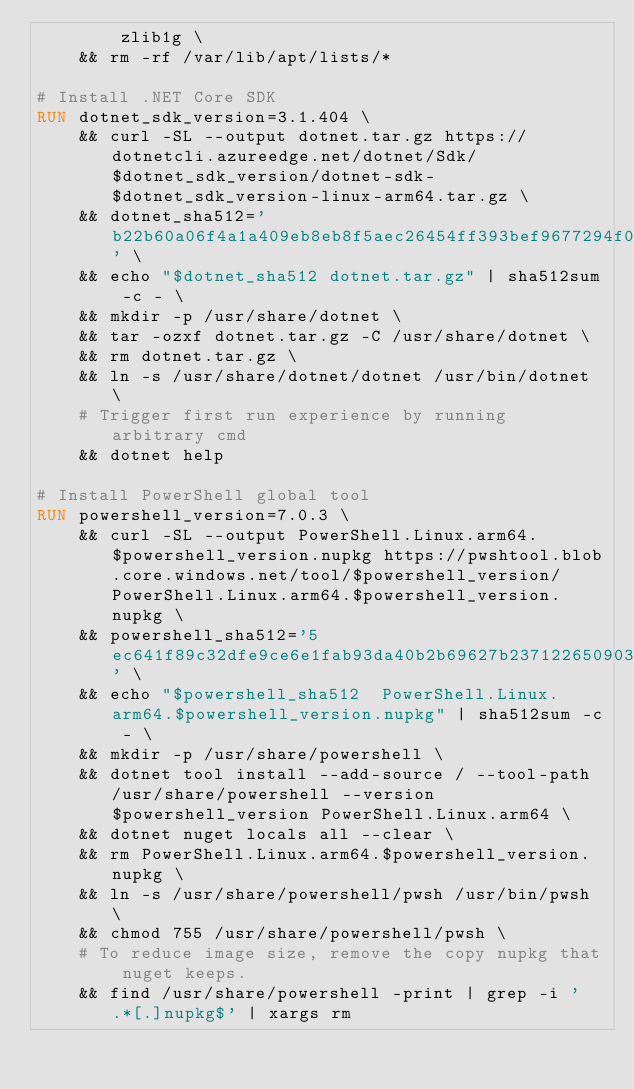<code> <loc_0><loc_0><loc_500><loc_500><_Dockerfile_>        zlib1g \
    && rm -rf /var/lib/apt/lists/*

# Install .NET Core SDK
RUN dotnet_sdk_version=3.1.404 \
    && curl -SL --output dotnet.tar.gz https://dotnetcli.azureedge.net/dotnet/Sdk/$dotnet_sdk_version/dotnet-sdk-$dotnet_sdk_version-linux-arm64.tar.gz \
    && dotnet_sha512='b22b60a06f4a1a409eb8eb8f5aec26454ff393bef9677294f0a9d61367caeb2a55fff1e4e282af5250365d27cee3b5cf7c31db8ff1c224f1c7225263b0e4a9aa' \
    && echo "$dotnet_sha512 dotnet.tar.gz" | sha512sum -c - \
    && mkdir -p /usr/share/dotnet \
    && tar -ozxf dotnet.tar.gz -C /usr/share/dotnet \
    && rm dotnet.tar.gz \
    && ln -s /usr/share/dotnet/dotnet /usr/bin/dotnet \
    # Trigger first run experience by running arbitrary cmd
    && dotnet help

# Install PowerShell global tool
RUN powershell_version=7.0.3 \
    && curl -SL --output PowerShell.Linux.arm64.$powershell_version.nupkg https://pwshtool.blob.core.windows.net/tool/$powershell_version/PowerShell.Linux.arm64.$powershell_version.nupkg \
    && powershell_sha512='5ec641f89c32dfe9ce6e1fab93da40b2b69627b23712265090353e0aa27dfc298f345b33e8bd67b490283754278a8adc5843e3857b6f995c51269b929a5783ed' \
    && echo "$powershell_sha512  PowerShell.Linux.arm64.$powershell_version.nupkg" | sha512sum -c - \
    && mkdir -p /usr/share/powershell \
    && dotnet tool install --add-source / --tool-path /usr/share/powershell --version $powershell_version PowerShell.Linux.arm64 \
    && dotnet nuget locals all --clear \
    && rm PowerShell.Linux.arm64.$powershell_version.nupkg \
    && ln -s /usr/share/powershell/pwsh /usr/bin/pwsh \
    && chmod 755 /usr/share/powershell/pwsh \
    # To reduce image size, remove the copy nupkg that nuget keeps.
    && find /usr/share/powershell -print | grep -i '.*[.]nupkg$' | xargs rm
</code> 